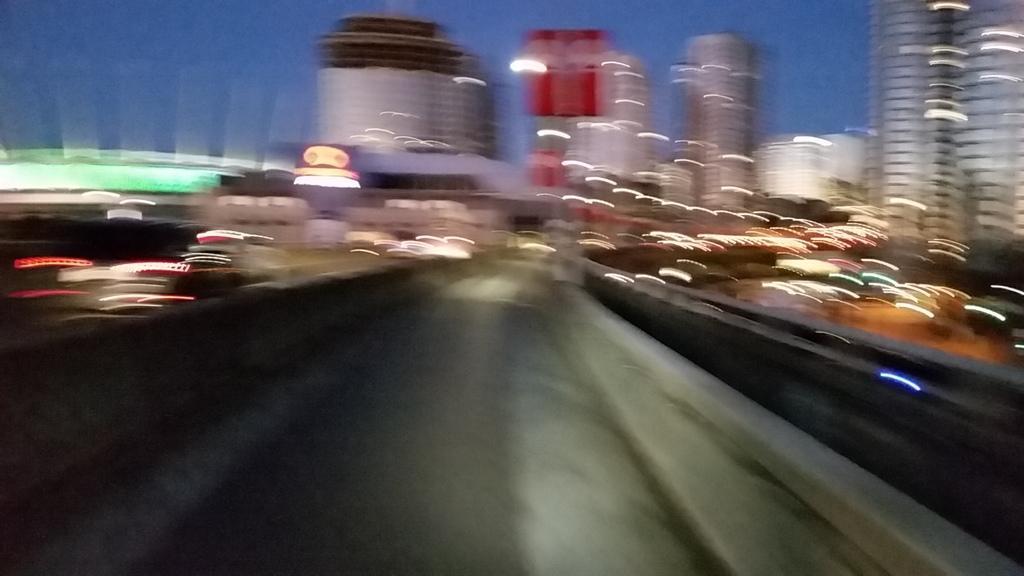Could you give a brief overview of what you see in this image? In this image we can see road, buildings, vehicles and sky. 